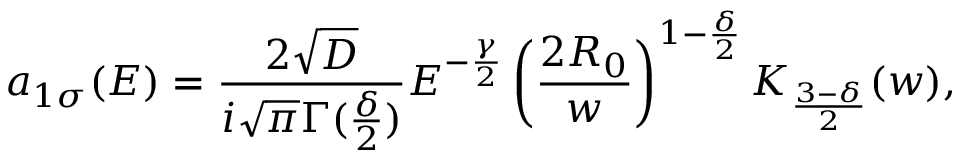Convert formula to latex. <formula><loc_0><loc_0><loc_500><loc_500>a _ { 1 \sigma } ( E ) = \frac { 2 \sqrt { D } } { i \sqrt { \pi } \Gamma ( \frac { \delta } { 2 } ) } E ^ { - \frac { \gamma } { 2 } } \left ( \frac { 2 R _ { 0 } } { w } \right ) ^ { 1 - \frac { \delta } { 2 } } K _ { \frac { 3 - \delta } { 2 } } ( w ) ,</formula> 